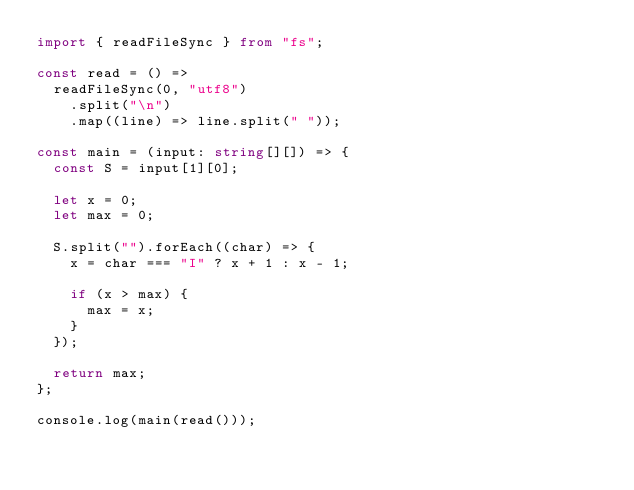Convert code to text. <code><loc_0><loc_0><loc_500><loc_500><_TypeScript_>import { readFileSync } from "fs";

const read = () =>
  readFileSync(0, "utf8")
    .split("\n")
    .map((line) => line.split(" "));

const main = (input: string[][]) => {
  const S = input[1][0];

  let x = 0;
  let max = 0;

  S.split("").forEach((char) => {
    x = char === "I" ? x + 1 : x - 1;

    if (x > max) {
      max = x;
    }
  });

  return max;
};

console.log(main(read()));
</code> 